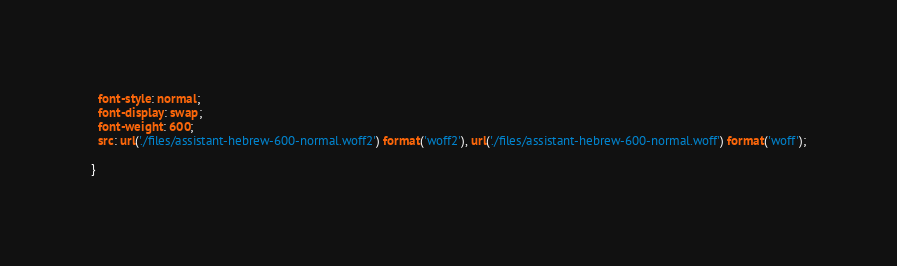Convert code to text. <code><loc_0><loc_0><loc_500><loc_500><_CSS_>  font-style: normal;
  font-display: swap;
  font-weight: 600;
  src: url('./files/assistant-hebrew-600-normal.woff2') format('woff2'), url('./files/assistant-hebrew-600-normal.woff') format('woff');
  
}
</code> 